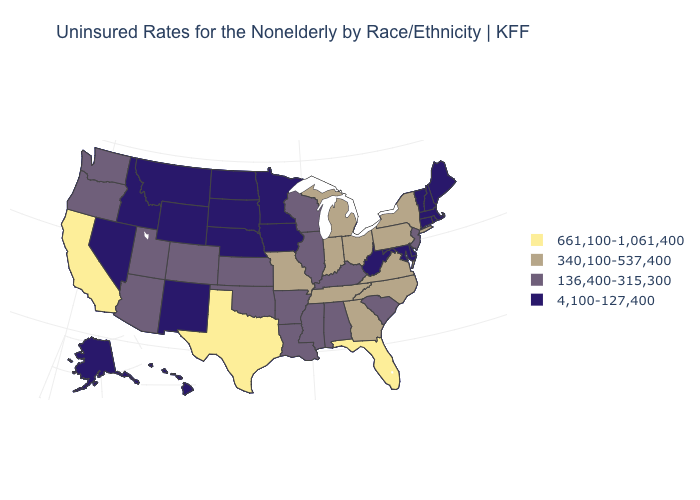Name the states that have a value in the range 136,400-315,300?
Quick response, please. Alabama, Arizona, Arkansas, Colorado, Illinois, Kansas, Kentucky, Louisiana, Mississippi, New Jersey, Oklahoma, Oregon, South Carolina, Utah, Washington, Wisconsin. What is the value of Maryland?
Quick response, please. 4,100-127,400. Does New Mexico have the highest value in the USA?
Give a very brief answer. No. Name the states that have a value in the range 4,100-127,400?
Be succinct. Alaska, Connecticut, Delaware, Hawaii, Idaho, Iowa, Maine, Maryland, Massachusetts, Minnesota, Montana, Nebraska, Nevada, New Hampshire, New Mexico, North Dakota, Rhode Island, South Dakota, Vermont, West Virginia, Wyoming. Does Maryland have the lowest value in the South?
Answer briefly. Yes. What is the value of Nebraska?
Short answer required. 4,100-127,400. What is the highest value in states that border Idaho?
Be succinct. 136,400-315,300. Name the states that have a value in the range 4,100-127,400?
Write a very short answer. Alaska, Connecticut, Delaware, Hawaii, Idaho, Iowa, Maine, Maryland, Massachusetts, Minnesota, Montana, Nebraska, Nevada, New Hampshire, New Mexico, North Dakota, Rhode Island, South Dakota, Vermont, West Virginia, Wyoming. Which states have the highest value in the USA?
Concise answer only. California, Florida, Texas. Name the states that have a value in the range 136,400-315,300?
Keep it brief. Alabama, Arizona, Arkansas, Colorado, Illinois, Kansas, Kentucky, Louisiana, Mississippi, New Jersey, Oklahoma, Oregon, South Carolina, Utah, Washington, Wisconsin. What is the highest value in states that border New York?
Short answer required. 340,100-537,400. What is the value of California?
Give a very brief answer. 661,100-1,061,400. What is the value of California?
Write a very short answer. 661,100-1,061,400. Among the states that border Rhode Island , which have the lowest value?
Give a very brief answer. Connecticut, Massachusetts. Among the states that border Pennsylvania , does West Virginia have the highest value?
Concise answer only. No. 